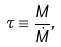<formula> <loc_0><loc_0><loc_500><loc_500>\tau \equiv \frac { M } { \dot { M } } ,</formula> 